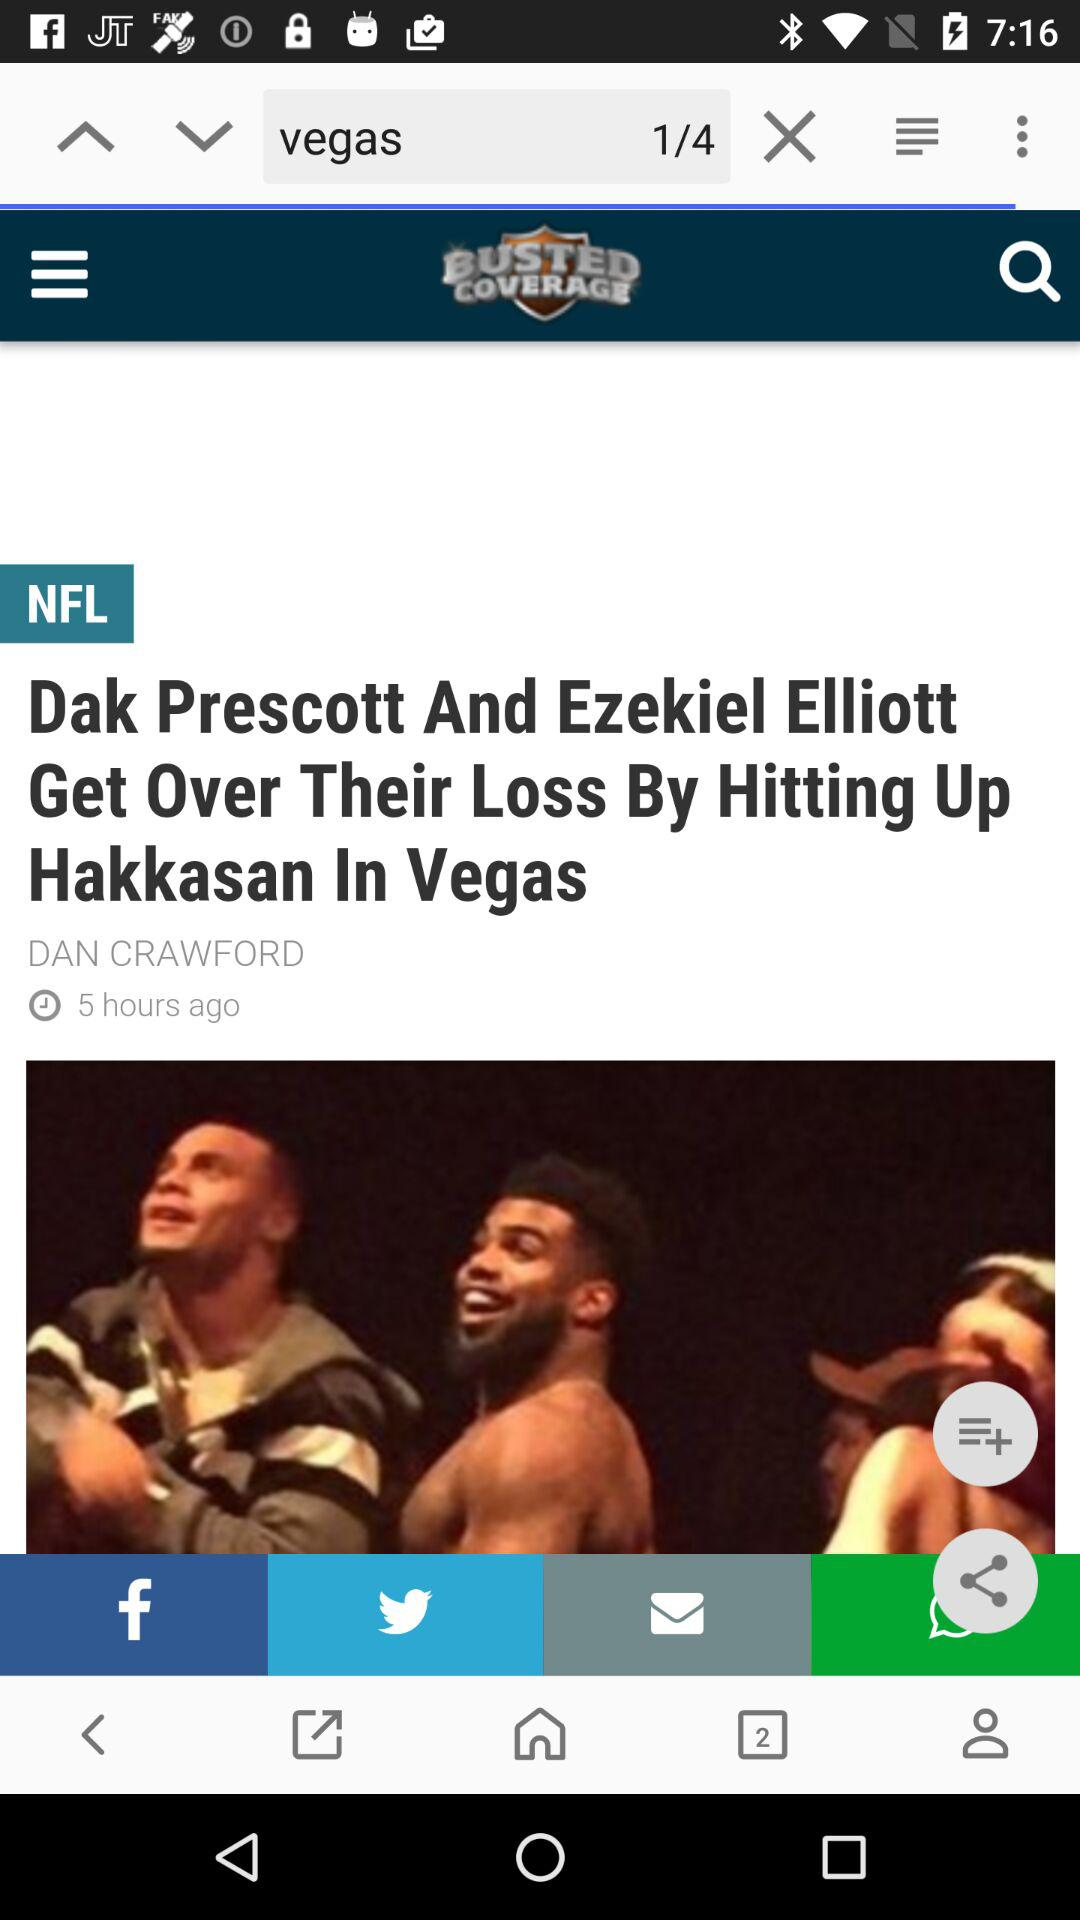What is the name of the company? The name of the company is "BUSTED COVERAGE". 